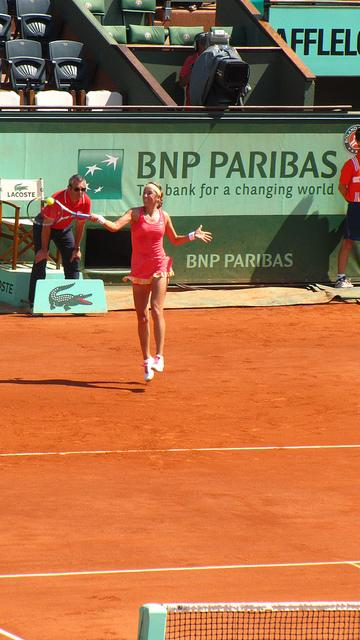What shirt brand is represented by the amphibious animal? lacoste 